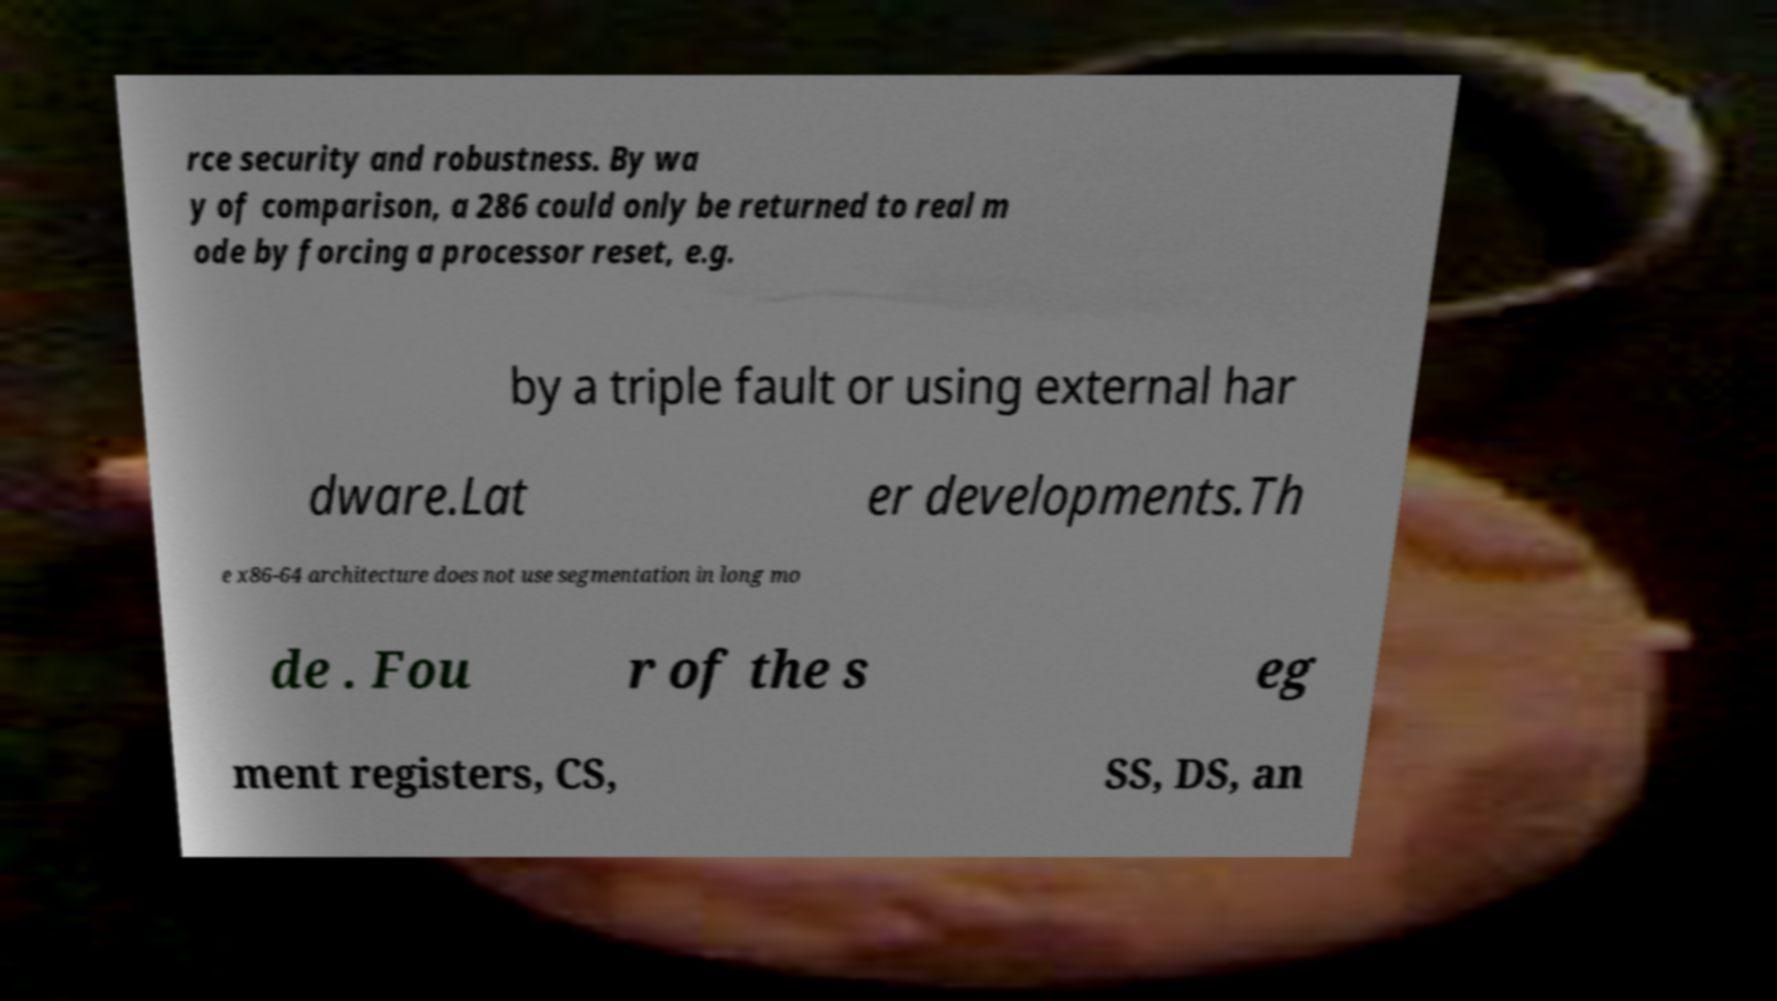Please read and relay the text visible in this image. What does it say? rce security and robustness. By wa y of comparison, a 286 could only be returned to real m ode by forcing a processor reset, e.g. by a triple fault or using external har dware.Lat er developments.Th e x86-64 architecture does not use segmentation in long mo de . Fou r of the s eg ment registers, CS, SS, DS, an 